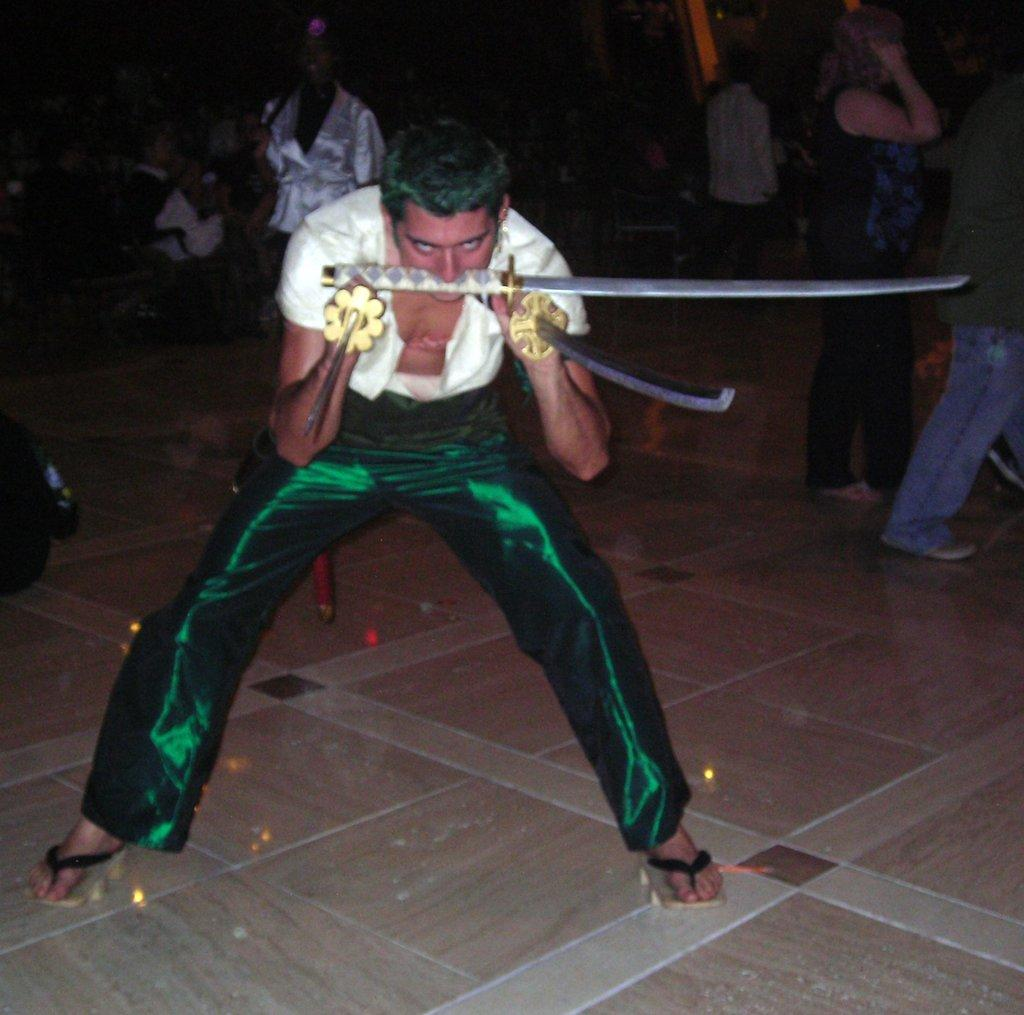How many people are in the image? There are people in the image, but the exact number is not specified. What are some people doing in the image? Some people are holding objects in the image. What can be found on the floor in the image? There are objects on the floor in the image. How does the floor appear in the image? The floor has light reflection in the image. What type of flowers can be seen growing on the tank in the image? There is no tank or flowers present in the image. What type of clouds can be seen in the image? The facts provided do not mention any clouds in the image. 